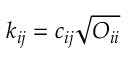Convert formula to latex. <formula><loc_0><loc_0><loc_500><loc_500>k _ { i j } = c _ { i j } \sqrt { O _ { i i } }</formula> 